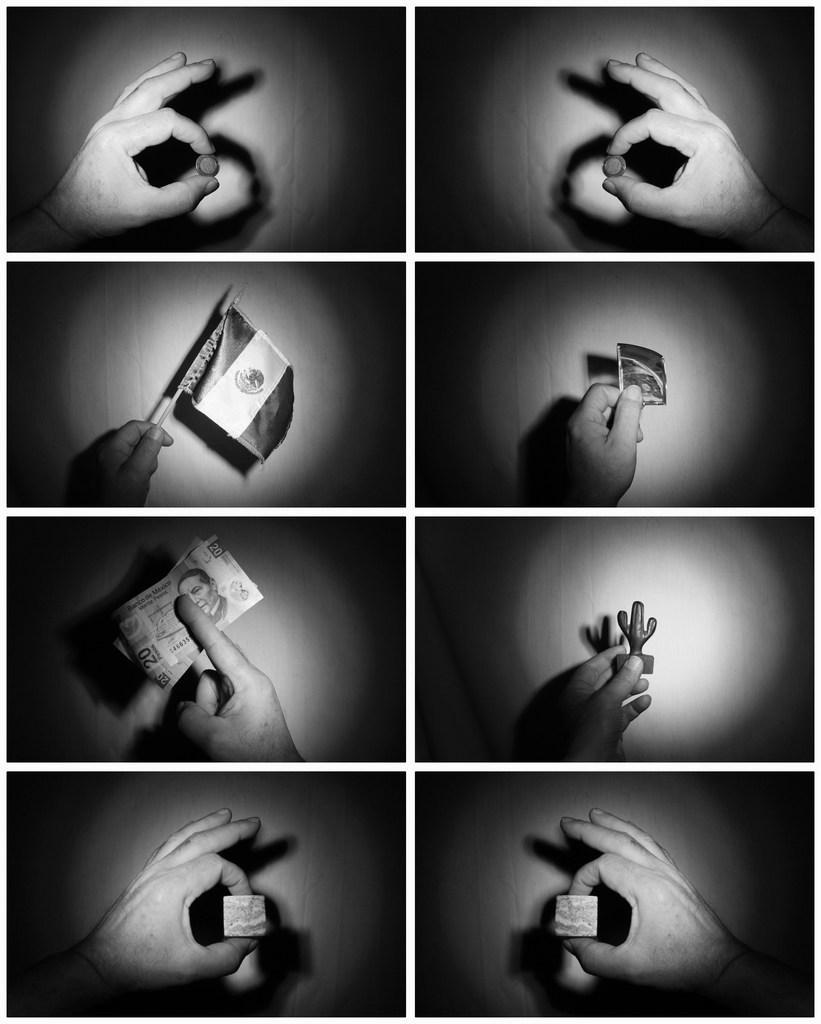Could you give a brief overview of what you see in this image? In this picture we can see a collage picture, here we can see a person hands, flag, currency note, flag and some objects. 